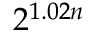Convert formula to latex. <formula><loc_0><loc_0><loc_500><loc_500>2 ^ { 1 . 0 2 n }</formula> 